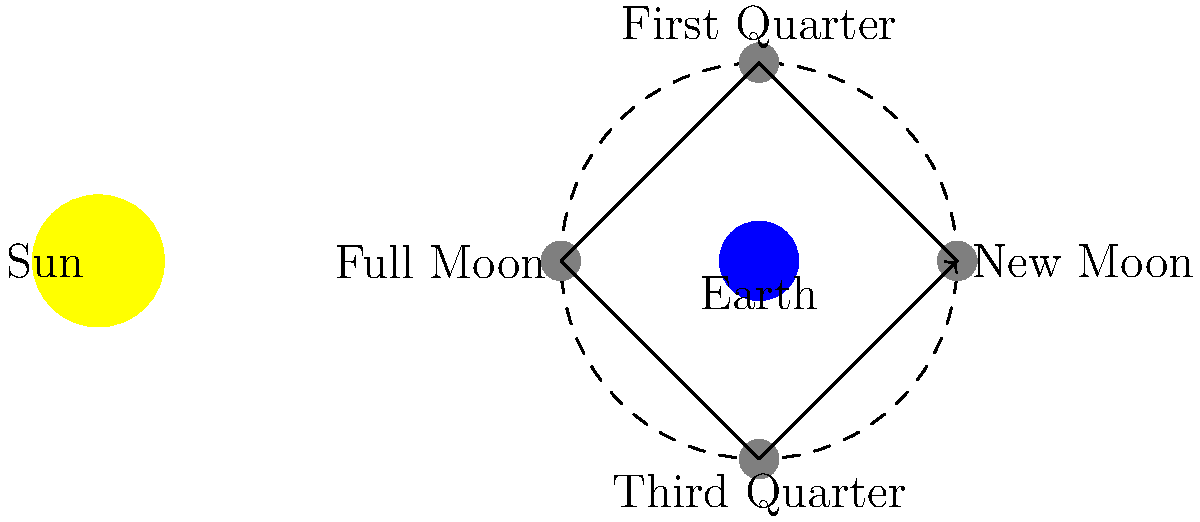As a game designer implementing a lunar cycle mechanic, you need to accurately model the moon's phases. Given the diagram showing the positions of the Sun, Earth, and Moon at different phases, what would be the correct sequence of moon phases as observed from Earth, starting from the New Moon position? To answer this question, we need to understand how the moon's position relative to the Earth and Sun affects its appearance from Earth. Let's break it down step-by-step:

1. New Moon: When the Moon is between the Earth and the Sun (position 1 in the diagram), its dark side faces Earth. This is the New Moon phase.

2. Moving counterclockwise (as indicated by the arrows), the next position (2) shows the Moon at a right angle to the Earth-Sun line. This is the First Quarter phase, where we see half of the Moon's illuminated surface.

3. Continuing counterclockwise, position 3 shows the Moon on the opposite side of Earth from the Sun. This is the Full Moon phase, where the entire illuminated surface is visible from Earth.

4. The final position (4) shows the Moon again at a right angle, but on the other side. This is the Third Quarter phase, where we again see half of the illuminated surface, but the opposite half compared to the First Quarter.

5. The cycle then repeats, returning to the New Moon position.

In game design terms, this cycle could be represented as a circular progression or a numerical value that increases from 0 to 1 and then resets, where 0 represents the New Moon, 0.25 the First Quarter, 0.5 the Full Moon, and 0.75 the Third Quarter.
Answer: New Moon, Waxing Crescent, First Quarter, Waxing Gibbous, Full Moon, Waning Gibbous, Third Quarter, Waning Crescent 